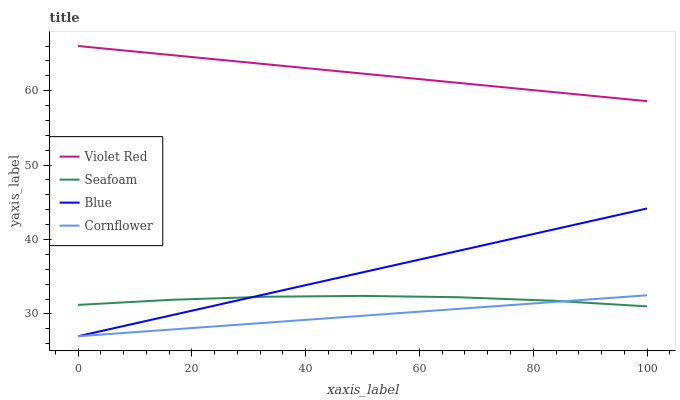Does Cornflower have the minimum area under the curve?
Answer yes or no. Yes. Does Violet Red have the maximum area under the curve?
Answer yes or no. Yes. Does Violet Red have the minimum area under the curve?
Answer yes or no. No. Does Cornflower have the maximum area under the curve?
Answer yes or no. No. Is Cornflower the smoothest?
Answer yes or no. Yes. Is Seafoam the roughest?
Answer yes or no. Yes. Is Violet Red the smoothest?
Answer yes or no. No. Is Violet Red the roughest?
Answer yes or no. No. Does Violet Red have the lowest value?
Answer yes or no. No. Does Cornflower have the highest value?
Answer yes or no. No. Is Cornflower less than Violet Red?
Answer yes or no. Yes. Is Violet Red greater than Seafoam?
Answer yes or no. Yes. Does Cornflower intersect Violet Red?
Answer yes or no. No. 